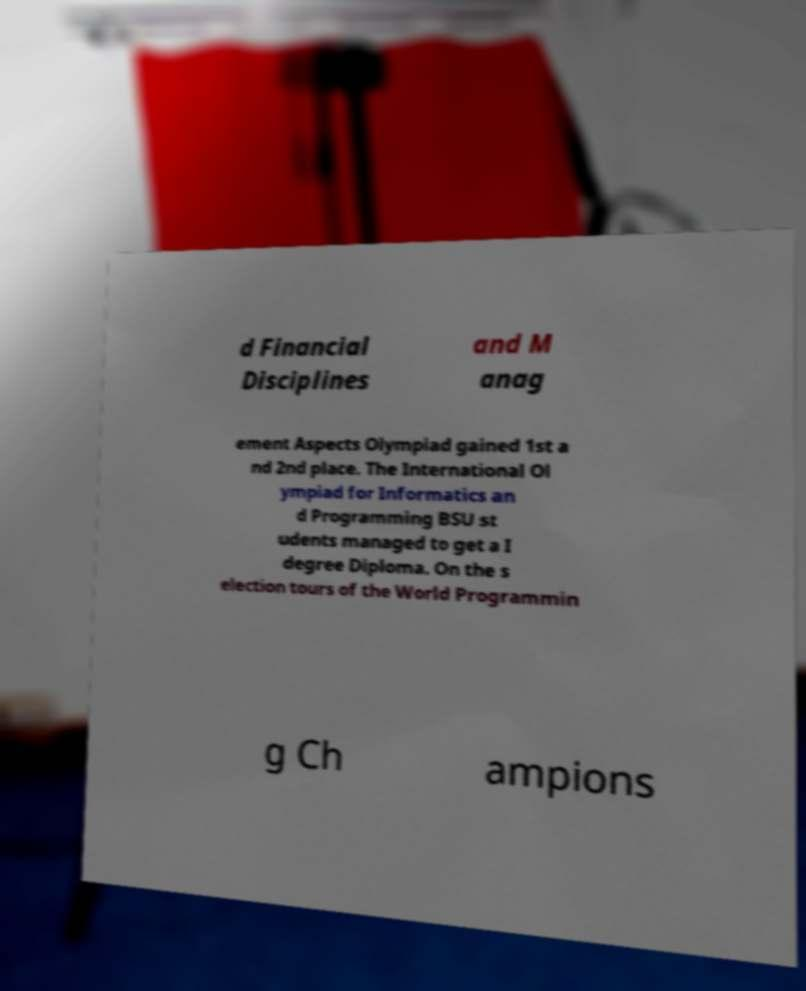Can you read and provide the text displayed in the image?This photo seems to have some interesting text. Can you extract and type it out for me? d Financial Disciplines and M anag ement Aspects Olympiad gained 1st a nd 2nd place. The International Ol ympiad for Informatics an d Programming BSU st udents managed to get a I degree Diploma. On the s election tours of the World Programmin g Ch ampions 